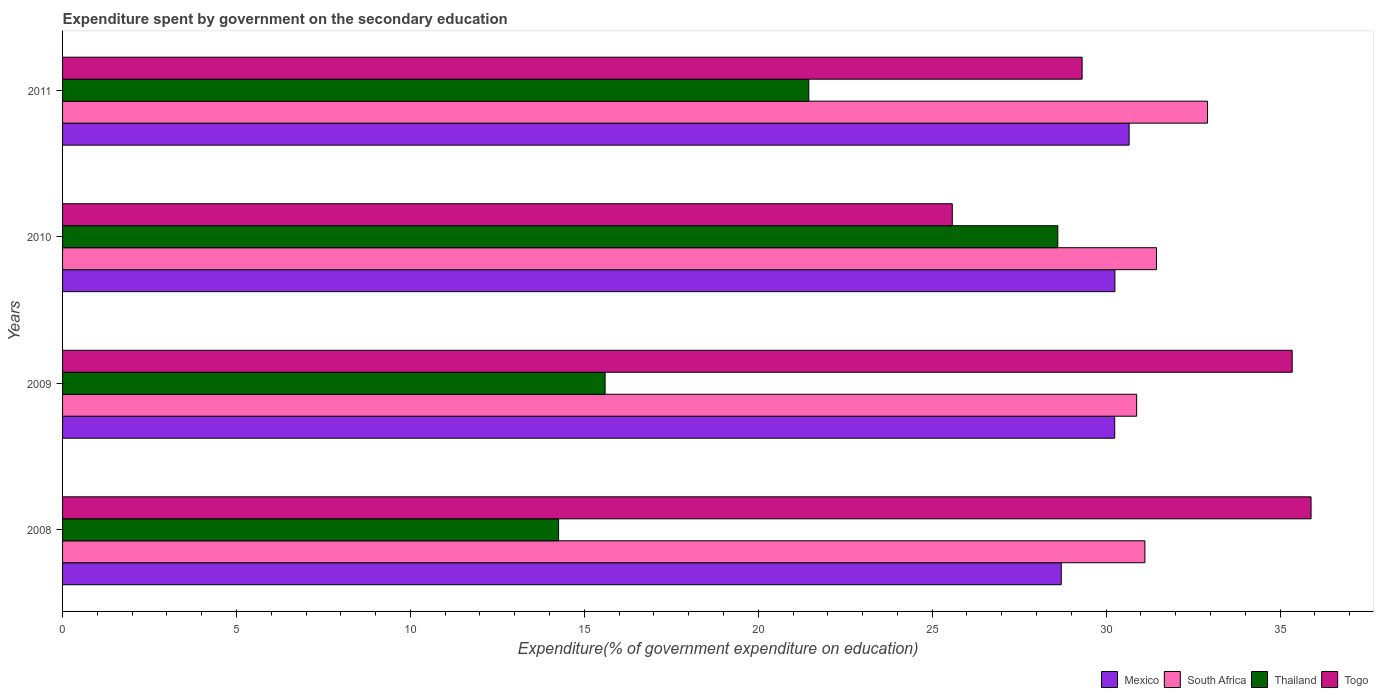How many groups of bars are there?
Your answer should be very brief. 4. Are the number of bars on each tick of the Y-axis equal?
Offer a terse response. Yes. How many bars are there on the 4th tick from the bottom?
Provide a succinct answer. 4. What is the expenditure spent by government on the secondary education in Mexico in 2010?
Ensure brevity in your answer.  30.25. Across all years, what is the maximum expenditure spent by government on the secondary education in Togo?
Keep it short and to the point. 35.89. Across all years, what is the minimum expenditure spent by government on the secondary education in Mexico?
Your response must be concise. 28.71. In which year was the expenditure spent by government on the secondary education in South Africa maximum?
Provide a short and direct response. 2011. What is the total expenditure spent by government on the secondary education in Togo in the graph?
Offer a terse response. 126.13. What is the difference between the expenditure spent by government on the secondary education in Togo in 2009 and that in 2010?
Provide a short and direct response. 9.77. What is the difference between the expenditure spent by government on the secondary education in Mexico in 2010 and the expenditure spent by government on the secondary education in Togo in 2011?
Offer a terse response. 0.94. What is the average expenditure spent by government on the secondary education in South Africa per year?
Your response must be concise. 31.59. In the year 2008, what is the difference between the expenditure spent by government on the secondary education in South Africa and expenditure spent by government on the secondary education in Mexico?
Give a very brief answer. 2.4. What is the ratio of the expenditure spent by government on the secondary education in Thailand in 2009 to that in 2010?
Offer a very short reply. 0.55. What is the difference between the highest and the second highest expenditure spent by government on the secondary education in Thailand?
Make the answer very short. 7.16. What is the difference between the highest and the lowest expenditure spent by government on the secondary education in South Africa?
Ensure brevity in your answer.  2.04. Is the sum of the expenditure spent by government on the secondary education in Thailand in 2008 and 2010 greater than the maximum expenditure spent by government on the secondary education in Mexico across all years?
Your answer should be compact. Yes. What does the 3rd bar from the top in 2011 represents?
Give a very brief answer. South Africa. What does the 3rd bar from the bottom in 2010 represents?
Offer a very short reply. Thailand. What is the difference between two consecutive major ticks on the X-axis?
Ensure brevity in your answer.  5. Does the graph contain any zero values?
Your answer should be compact. No. Does the graph contain grids?
Your answer should be compact. No. How many legend labels are there?
Provide a succinct answer. 4. How are the legend labels stacked?
Give a very brief answer. Horizontal. What is the title of the graph?
Provide a succinct answer. Expenditure spent by government on the secondary education. What is the label or title of the X-axis?
Ensure brevity in your answer.  Expenditure(% of government expenditure on education). What is the Expenditure(% of government expenditure on education) in Mexico in 2008?
Offer a very short reply. 28.71. What is the Expenditure(% of government expenditure on education) of South Africa in 2008?
Your answer should be compact. 31.12. What is the Expenditure(% of government expenditure on education) in Thailand in 2008?
Ensure brevity in your answer.  14.26. What is the Expenditure(% of government expenditure on education) of Togo in 2008?
Offer a very short reply. 35.89. What is the Expenditure(% of government expenditure on education) of Mexico in 2009?
Keep it short and to the point. 30.25. What is the Expenditure(% of government expenditure on education) of South Africa in 2009?
Provide a succinct answer. 30.88. What is the Expenditure(% of government expenditure on education) of Thailand in 2009?
Provide a succinct answer. 15.6. What is the Expenditure(% of government expenditure on education) in Togo in 2009?
Provide a succinct answer. 35.35. What is the Expenditure(% of government expenditure on education) of Mexico in 2010?
Make the answer very short. 30.25. What is the Expenditure(% of government expenditure on education) in South Africa in 2010?
Your answer should be compact. 31.45. What is the Expenditure(% of government expenditure on education) in Thailand in 2010?
Provide a short and direct response. 28.61. What is the Expenditure(% of government expenditure on education) of Togo in 2010?
Provide a succinct answer. 25.58. What is the Expenditure(% of government expenditure on education) in Mexico in 2011?
Offer a terse response. 30.66. What is the Expenditure(% of government expenditure on education) in South Africa in 2011?
Your answer should be very brief. 32.92. What is the Expenditure(% of government expenditure on education) in Thailand in 2011?
Your response must be concise. 21.45. What is the Expenditure(% of government expenditure on education) of Togo in 2011?
Offer a terse response. 29.31. Across all years, what is the maximum Expenditure(% of government expenditure on education) of Mexico?
Offer a terse response. 30.66. Across all years, what is the maximum Expenditure(% of government expenditure on education) in South Africa?
Your answer should be very brief. 32.92. Across all years, what is the maximum Expenditure(% of government expenditure on education) of Thailand?
Your answer should be compact. 28.61. Across all years, what is the maximum Expenditure(% of government expenditure on education) in Togo?
Your answer should be very brief. 35.89. Across all years, what is the minimum Expenditure(% of government expenditure on education) of Mexico?
Your answer should be compact. 28.71. Across all years, what is the minimum Expenditure(% of government expenditure on education) of South Africa?
Offer a terse response. 30.88. Across all years, what is the minimum Expenditure(% of government expenditure on education) of Thailand?
Give a very brief answer. 14.26. Across all years, what is the minimum Expenditure(% of government expenditure on education) in Togo?
Give a very brief answer. 25.58. What is the total Expenditure(% of government expenditure on education) in Mexico in the graph?
Your answer should be very brief. 119.88. What is the total Expenditure(% of government expenditure on education) of South Africa in the graph?
Your answer should be compact. 126.36. What is the total Expenditure(% of government expenditure on education) of Thailand in the graph?
Give a very brief answer. 79.92. What is the total Expenditure(% of government expenditure on education) of Togo in the graph?
Ensure brevity in your answer.  126.13. What is the difference between the Expenditure(% of government expenditure on education) in Mexico in 2008 and that in 2009?
Your answer should be very brief. -1.54. What is the difference between the Expenditure(% of government expenditure on education) in South Africa in 2008 and that in 2009?
Your answer should be compact. 0.24. What is the difference between the Expenditure(% of government expenditure on education) in Thailand in 2008 and that in 2009?
Your response must be concise. -1.34. What is the difference between the Expenditure(% of government expenditure on education) of Togo in 2008 and that in 2009?
Keep it short and to the point. 0.54. What is the difference between the Expenditure(% of government expenditure on education) in Mexico in 2008 and that in 2010?
Your answer should be compact. -1.54. What is the difference between the Expenditure(% of government expenditure on education) in South Africa in 2008 and that in 2010?
Offer a very short reply. -0.33. What is the difference between the Expenditure(% of government expenditure on education) of Thailand in 2008 and that in 2010?
Provide a succinct answer. -14.35. What is the difference between the Expenditure(% of government expenditure on education) in Togo in 2008 and that in 2010?
Give a very brief answer. 10.31. What is the difference between the Expenditure(% of government expenditure on education) of Mexico in 2008 and that in 2011?
Give a very brief answer. -1.95. What is the difference between the Expenditure(% of government expenditure on education) in South Africa in 2008 and that in 2011?
Your answer should be very brief. -1.8. What is the difference between the Expenditure(% of government expenditure on education) of Thailand in 2008 and that in 2011?
Your answer should be compact. -7.19. What is the difference between the Expenditure(% of government expenditure on education) of Togo in 2008 and that in 2011?
Keep it short and to the point. 6.58. What is the difference between the Expenditure(% of government expenditure on education) in Mexico in 2009 and that in 2010?
Provide a succinct answer. -0.01. What is the difference between the Expenditure(% of government expenditure on education) in South Africa in 2009 and that in 2010?
Your answer should be very brief. -0.57. What is the difference between the Expenditure(% of government expenditure on education) in Thailand in 2009 and that in 2010?
Ensure brevity in your answer.  -13.01. What is the difference between the Expenditure(% of government expenditure on education) of Togo in 2009 and that in 2010?
Make the answer very short. 9.77. What is the difference between the Expenditure(% of government expenditure on education) in Mexico in 2009 and that in 2011?
Your response must be concise. -0.41. What is the difference between the Expenditure(% of government expenditure on education) in South Africa in 2009 and that in 2011?
Give a very brief answer. -2.04. What is the difference between the Expenditure(% of government expenditure on education) in Thailand in 2009 and that in 2011?
Make the answer very short. -5.86. What is the difference between the Expenditure(% of government expenditure on education) of Togo in 2009 and that in 2011?
Offer a very short reply. 6.04. What is the difference between the Expenditure(% of government expenditure on education) in Mexico in 2010 and that in 2011?
Offer a terse response. -0.41. What is the difference between the Expenditure(% of government expenditure on education) of South Africa in 2010 and that in 2011?
Provide a succinct answer. -1.47. What is the difference between the Expenditure(% of government expenditure on education) in Thailand in 2010 and that in 2011?
Offer a terse response. 7.16. What is the difference between the Expenditure(% of government expenditure on education) of Togo in 2010 and that in 2011?
Your response must be concise. -3.73. What is the difference between the Expenditure(% of government expenditure on education) in Mexico in 2008 and the Expenditure(% of government expenditure on education) in South Africa in 2009?
Offer a terse response. -2.17. What is the difference between the Expenditure(% of government expenditure on education) in Mexico in 2008 and the Expenditure(% of government expenditure on education) in Thailand in 2009?
Give a very brief answer. 13.11. What is the difference between the Expenditure(% of government expenditure on education) in Mexico in 2008 and the Expenditure(% of government expenditure on education) in Togo in 2009?
Give a very brief answer. -6.64. What is the difference between the Expenditure(% of government expenditure on education) in South Africa in 2008 and the Expenditure(% of government expenditure on education) in Thailand in 2009?
Make the answer very short. 15.52. What is the difference between the Expenditure(% of government expenditure on education) of South Africa in 2008 and the Expenditure(% of government expenditure on education) of Togo in 2009?
Offer a very short reply. -4.23. What is the difference between the Expenditure(% of government expenditure on education) of Thailand in 2008 and the Expenditure(% of government expenditure on education) of Togo in 2009?
Your answer should be very brief. -21.09. What is the difference between the Expenditure(% of government expenditure on education) of Mexico in 2008 and the Expenditure(% of government expenditure on education) of South Africa in 2010?
Keep it short and to the point. -2.74. What is the difference between the Expenditure(% of government expenditure on education) in Mexico in 2008 and the Expenditure(% of government expenditure on education) in Thailand in 2010?
Offer a very short reply. 0.1. What is the difference between the Expenditure(% of government expenditure on education) in Mexico in 2008 and the Expenditure(% of government expenditure on education) in Togo in 2010?
Your answer should be very brief. 3.13. What is the difference between the Expenditure(% of government expenditure on education) of South Africa in 2008 and the Expenditure(% of government expenditure on education) of Thailand in 2010?
Keep it short and to the point. 2.5. What is the difference between the Expenditure(% of government expenditure on education) of South Africa in 2008 and the Expenditure(% of government expenditure on education) of Togo in 2010?
Your answer should be very brief. 5.54. What is the difference between the Expenditure(% of government expenditure on education) of Thailand in 2008 and the Expenditure(% of government expenditure on education) of Togo in 2010?
Make the answer very short. -11.32. What is the difference between the Expenditure(% of government expenditure on education) of Mexico in 2008 and the Expenditure(% of government expenditure on education) of South Africa in 2011?
Provide a succinct answer. -4.21. What is the difference between the Expenditure(% of government expenditure on education) of Mexico in 2008 and the Expenditure(% of government expenditure on education) of Thailand in 2011?
Provide a short and direct response. 7.26. What is the difference between the Expenditure(% of government expenditure on education) in Mexico in 2008 and the Expenditure(% of government expenditure on education) in Togo in 2011?
Offer a terse response. -0.6. What is the difference between the Expenditure(% of government expenditure on education) of South Africa in 2008 and the Expenditure(% of government expenditure on education) of Thailand in 2011?
Make the answer very short. 9.66. What is the difference between the Expenditure(% of government expenditure on education) in South Africa in 2008 and the Expenditure(% of government expenditure on education) in Togo in 2011?
Provide a short and direct response. 1.8. What is the difference between the Expenditure(% of government expenditure on education) of Thailand in 2008 and the Expenditure(% of government expenditure on education) of Togo in 2011?
Provide a short and direct response. -15.05. What is the difference between the Expenditure(% of government expenditure on education) in Mexico in 2009 and the Expenditure(% of government expenditure on education) in South Africa in 2010?
Offer a very short reply. -1.2. What is the difference between the Expenditure(% of government expenditure on education) in Mexico in 2009 and the Expenditure(% of government expenditure on education) in Thailand in 2010?
Keep it short and to the point. 1.64. What is the difference between the Expenditure(% of government expenditure on education) of Mexico in 2009 and the Expenditure(% of government expenditure on education) of Togo in 2010?
Your answer should be compact. 4.67. What is the difference between the Expenditure(% of government expenditure on education) of South Africa in 2009 and the Expenditure(% of government expenditure on education) of Thailand in 2010?
Make the answer very short. 2.27. What is the difference between the Expenditure(% of government expenditure on education) in South Africa in 2009 and the Expenditure(% of government expenditure on education) in Togo in 2010?
Provide a short and direct response. 5.3. What is the difference between the Expenditure(% of government expenditure on education) in Thailand in 2009 and the Expenditure(% of government expenditure on education) in Togo in 2010?
Offer a terse response. -9.98. What is the difference between the Expenditure(% of government expenditure on education) in Mexico in 2009 and the Expenditure(% of government expenditure on education) in South Africa in 2011?
Offer a very short reply. -2.67. What is the difference between the Expenditure(% of government expenditure on education) in Mexico in 2009 and the Expenditure(% of government expenditure on education) in Thailand in 2011?
Your answer should be compact. 8.8. What is the difference between the Expenditure(% of government expenditure on education) in Mexico in 2009 and the Expenditure(% of government expenditure on education) in Togo in 2011?
Your answer should be very brief. 0.94. What is the difference between the Expenditure(% of government expenditure on education) of South Africa in 2009 and the Expenditure(% of government expenditure on education) of Thailand in 2011?
Ensure brevity in your answer.  9.43. What is the difference between the Expenditure(% of government expenditure on education) of South Africa in 2009 and the Expenditure(% of government expenditure on education) of Togo in 2011?
Offer a very short reply. 1.57. What is the difference between the Expenditure(% of government expenditure on education) of Thailand in 2009 and the Expenditure(% of government expenditure on education) of Togo in 2011?
Your answer should be compact. -13.71. What is the difference between the Expenditure(% of government expenditure on education) of Mexico in 2010 and the Expenditure(% of government expenditure on education) of South Africa in 2011?
Keep it short and to the point. -2.66. What is the difference between the Expenditure(% of government expenditure on education) of Mexico in 2010 and the Expenditure(% of government expenditure on education) of Thailand in 2011?
Make the answer very short. 8.8. What is the difference between the Expenditure(% of government expenditure on education) of Mexico in 2010 and the Expenditure(% of government expenditure on education) of Togo in 2011?
Ensure brevity in your answer.  0.94. What is the difference between the Expenditure(% of government expenditure on education) in South Africa in 2010 and the Expenditure(% of government expenditure on education) in Thailand in 2011?
Give a very brief answer. 10. What is the difference between the Expenditure(% of government expenditure on education) in South Africa in 2010 and the Expenditure(% of government expenditure on education) in Togo in 2011?
Keep it short and to the point. 2.14. What is the difference between the Expenditure(% of government expenditure on education) of Thailand in 2010 and the Expenditure(% of government expenditure on education) of Togo in 2011?
Offer a very short reply. -0.7. What is the average Expenditure(% of government expenditure on education) of Mexico per year?
Ensure brevity in your answer.  29.97. What is the average Expenditure(% of government expenditure on education) in South Africa per year?
Offer a terse response. 31.59. What is the average Expenditure(% of government expenditure on education) in Thailand per year?
Ensure brevity in your answer.  19.98. What is the average Expenditure(% of government expenditure on education) of Togo per year?
Your answer should be compact. 31.53. In the year 2008, what is the difference between the Expenditure(% of government expenditure on education) of Mexico and Expenditure(% of government expenditure on education) of South Africa?
Offer a terse response. -2.4. In the year 2008, what is the difference between the Expenditure(% of government expenditure on education) in Mexico and Expenditure(% of government expenditure on education) in Thailand?
Ensure brevity in your answer.  14.45. In the year 2008, what is the difference between the Expenditure(% of government expenditure on education) of Mexico and Expenditure(% of government expenditure on education) of Togo?
Offer a terse response. -7.18. In the year 2008, what is the difference between the Expenditure(% of government expenditure on education) of South Africa and Expenditure(% of government expenditure on education) of Thailand?
Offer a terse response. 16.86. In the year 2008, what is the difference between the Expenditure(% of government expenditure on education) in South Africa and Expenditure(% of government expenditure on education) in Togo?
Your answer should be compact. -4.78. In the year 2008, what is the difference between the Expenditure(% of government expenditure on education) in Thailand and Expenditure(% of government expenditure on education) in Togo?
Give a very brief answer. -21.63. In the year 2009, what is the difference between the Expenditure(% of government expenditure on education) of Mexico and Expenditure(% of government expenditure on education) of South Africa?
Provide a short and direct response. -0.63. In the year 2009, what is the difference between the Expenditure(% of government expenditure on education) of Mexico and Expenditure(% of government expenditure on education) of Thailand?
Offer a very short reply. 14.65. In the year 2009, what is the difference between the Expenditure(% of government expenditure on education) in Mexico and Expenditure(% of government expenditure on education) in Togo?
Give a very brief answer. -5.1. In the year 2009, what is the difference between the Expenditure(% of government expenditure on education) in South Africa and Expenditure(% of government expenditure on education) in Thailand?
Offer a terse response. 15.28. In the year 2009, what is the difference between the Expenditure(% of government expenditure on education) in South Africa and Expenditure(% of government expenditure on education) in Togo?
Offer a terse response. -4.47. In the year 2009, what is the difference between the Expenditure(% of government expenditure on education) of Thailand and Expenditure(% of government expenditure on education) of Togo?
Give a very brief answer. -19.75. In the year 2010, what is the difference between the Expenditure(% of government expenditure on education) of Mexico and Expenditure(% of government expenditure on education) of South Africa?
Ensure brevity in your answer.  -1.2. In the year 2010, what is the difference between the Expenditure(% of government expenditure on education) in Mexico and Expenditure(% of government expenditure on education) in Thailand?
Your answer should be very brief. 1.64. In the year 2010, what is the difference between the Expenditure(% of government expenditure on education) in Mexico and Expenditure(% of government expenditure on education) in Togo?
Make the answer very short. 4.67. In the year 2010, what is the difference between the Expenditure(% of government expenditure on education) in South Africa and Expenditure(% of government expenditure on education) in Thailand?
Your response must be concise. 2.84. In the year 2010, what is the difference between the Expenditure(% of government expenditure on education) in South Africa and Expenditure(% of government expenditure on education) in Togo?
Keep it short and to the point. 5.87. In the year 2010, what is the difference between the Expenditure(% of government expenditure on education) of Thailand and Expenditure(% of government expenditure on education) of Togo?
Your response must be concise. 3.03. In the year 2011, what is the difference between the Expenditure(% of government expenditure on education) in Mexico and Expenditure(% of government expenditure on education) in South Africa?
Give a very brief answer. -2.25. In the year 2011, what is the difference between the Expenditure(% of government expenditure on education) of Mexico and Expenditure(% of government expenditure on education) of Thailand?
Keep it short and to the point. 9.21. In the year 2011, what is the difference between the Expenditure(% of government expenditure on education) of Mexico and Expenditure(% of government expenditure on education) of Togo?
Your answer should be compact. 1.35. In the year 2011, what is the difference between the Expenditure(% of government expenditure on education) in South Africa and Expenditure(% of government expenditure on education) in Thailand?
Provide a succinct answer. 11.46. In the year 2011, what is the difference between the Expenditure(% of government expenditure on education) in South Africa and Expenditure(% of government expenditure on education) in Togo?
Make the answer very short. 3.61. In the year 2011, what is the difference between the Expenditure(% of government expenditure on education) of Thailand and Expenditure(% of government expenditure on education) of Togo?
Make the answer very short. -7.86. What is the ratio of the Expenditure(% of government expenditure on education) of Mexico in 2008 to that in 2009?
Keep it short and to the point. 0.95. What is the ratio of the Expenditure(% of government expenditure on education) in South Africa in 2008 to that in 2009?
Provide a short and direct response. 1.01. What is the ratio of the Expenditure(% of government expenditure on education) of Thailand in 2008 to that in 2009?
Ensure brevity in your answer.  0.91. What is the ratio of the Expenditure(% of government expenditure on education) in Togo in 2008 to that in 2009?
Your answer should be compact. 1.02. What is the ratio of the Expenditure(% of government expenditure on education) in Mexico in 2008 to that in 2010?
Your response must be concise. 0.95. What is the ratio of the Expenditure(% of government expenditure on education) in South Africa in 2008 to that in 2010?
Give a very brief answer. 0.99. What is the ratio of the Expenditure(% of government expenditure on education) of Thailand in 2008 to that in 2010?
Make the answer very short. 0.5. What is the ratio of the Expenditure(% of government expenditure on education) in Togo in 2008 to that in 2010?
Your answer should be compact. 1.4. What is the ratio of the Expenditure(% of government expenditure on education) of Mexico in 2008 to that in 2011?
Give a very brief answer. 0.94. What is the ratio of the Expenditure(% of government expenditure on education) of South Africa in 2008 to that in 2011?
Provide a short and direct response. 0.95. What is the ratio of the Expenditure(% of government expenditure on education) in Thailand in 2008 to that in 2011?
Your answer should be very brief. 0.66. What is the ratio of the Expenditure(% of government expenditure on education) in Togo in 2008 to that in 2011?
Provide a succinct answer. 1.22. What is the ratio of the Expenditure(% of government expenditure on education) of Mexico in 2009 to that in 2010?
Keep it short and to the point. 1. What is the ratio of the Expenditure(% of government expenditure on education) of South Africa in 2009 to that in 2010?
Offer a very short reply. 0.98. What is the ratio of the Expenditure(% of government expenditure on education) in Thailand in 2009 to that in 2010?
Your answer should be compact. 0.55. What is the ratio of the Expenditure(% of government expenditure on education) of Togo in 2009 to that in 2010?
Keep it short and to the point. 1.38. What is the ratio of the Expenditure(% of government expenditure on education) of Mexico in 2009 to that in 2011?
Give a very brief answer. 0.99. What is the ratio of the Expenditure(% of government expenditure on education) of South Africa in 2009 to that in 2011?
Offer a terse response. 0.94. What is the ratio of the Expenditure(% of government expenditure on education) of Thailand in 2009 to that in 2011?
Your answer should be very brief. 0.73. What is the ratio of the Expenditure(% of government expenditure on education) of Togo in 2009 to that in 2011?
Give a very brief answer. 1.21. What is the ratio of the Expenditure(% of government expenditure on education) in Mexico in 2010 to that in 2011?
Your answer should be very brief. 0.99. What is the ratio of the Expenditure(% of government expenditure on education) of South Africa in 2010 to that in 2011?
Provide a short and direct response. 0.96. What is the ratio of the Expenditure(% of government expenditure on education) in Thailand in 2010 to that in 2011?
Your answer should be compact. 1.33. What is the ratio of the Expenditure(% of government expenditure on education) of Togo in 2010 to that in 2011?
Provide a short and direct response. 0.87. What is the difference between the highest and the second highest Expenditure(% of government expenditure on education) in Mexico?
Keep it short and to the point. 0.41. What is the difference between the highest and the second highest Expenditure(% of government expenditure on education) of South Africa?
Keep it short and to the point. 1.47. What is the difference between the highest and the second highest Expenditure(% of government expenditure on education) in Thailand?
Provide a short and direct response. 7.16. What is the difference between the highest and the second highest Expenditure(% of government expenditure on education) in Togo?
Your answer should be compact. 0.54. What is the difference between the highest and the lowest Expenditure(% of government expenditure on education) of Mexico?
Offer a terse response. 1.95. What is the difference between the highest and the lowest Expenditure(% of government expenditure on education) of South Africa?
Provide a succinct answer. 2.04. What is the difference between the highest and the lowest Expenditure(% of government expenditure on education) of Thailand?
Provide a succinct answer. 14.35. What is the difference between the highest and the lowest Expenditure(% of government expenditure on education) in Togo?
Offer a terse response. 10.31. 